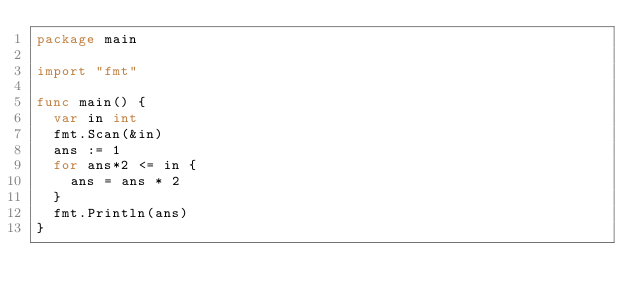Convert code to text. <code><loc_0><loc_0><loc_500><loc_500><_Go_>package main

import "fmt"

func main() {
	var in int
	fmt.Scan(&in)
	ans := 1
	for ans*2 <= in {
		ans = ans * 2
	}
	fmt.Println(ans)
}
</code> 